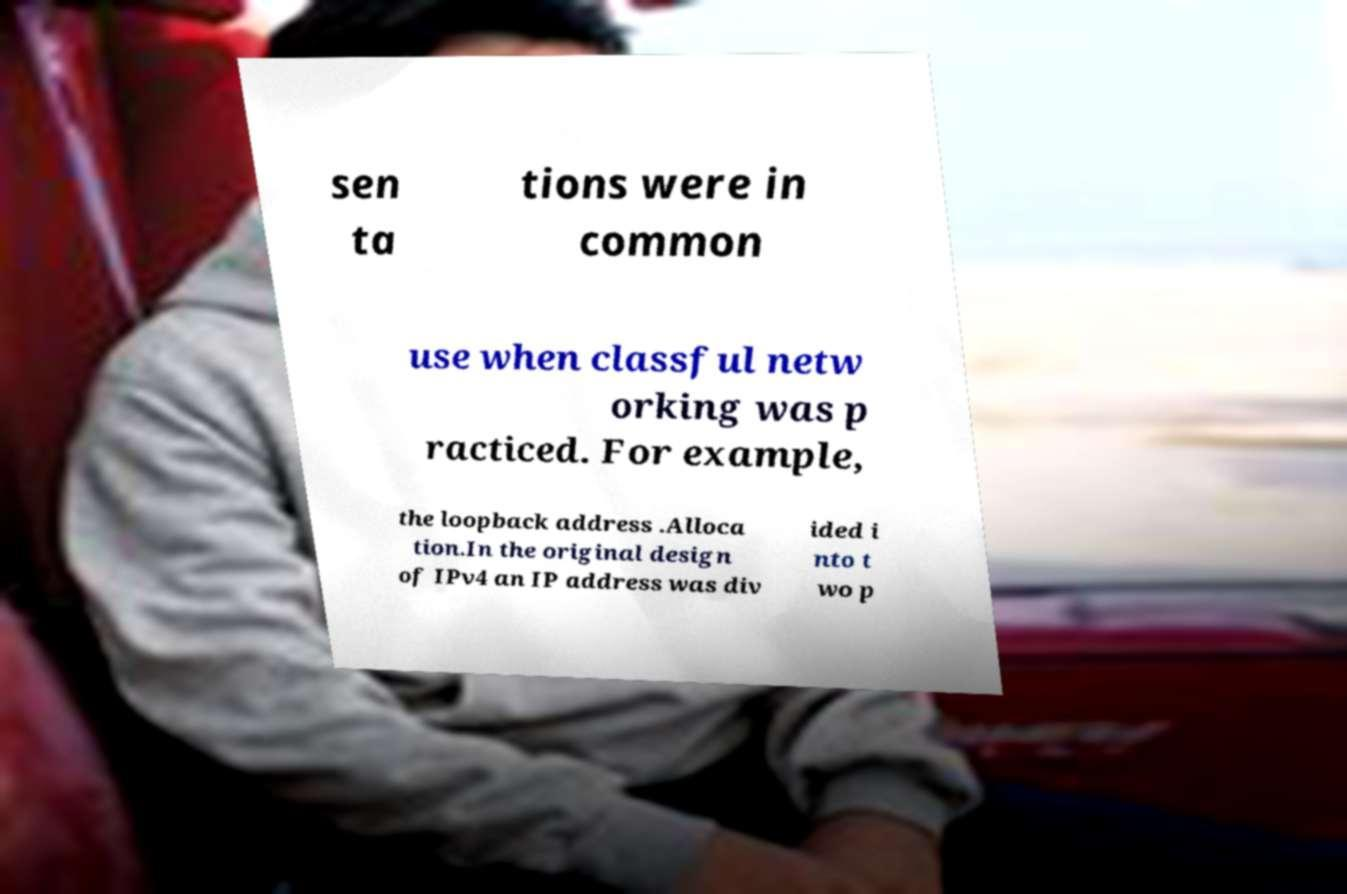What messages or text are displayed in this image? I need them in a readable, typed format. sen ta tions were in common use when classful netw orking was p racticed. For example, the loopback address .Alloca tion.In the original design of IPv4 an IP address was div ided i nto t wo p 